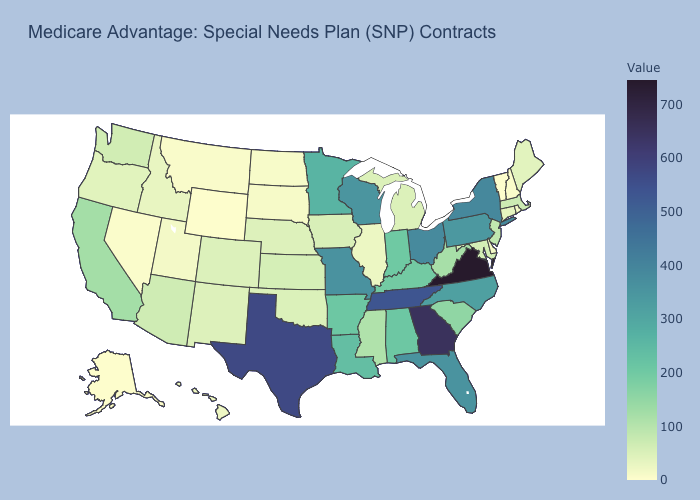Does Mississippi have a higher value than Arkansas?
Concise answer only. No. Is the legend a continuous bar?
Keep it brief. Yes. Does Florida have the lowest value in the USA?
Write a very short answer. No. Does Vermont have the lowest value in the USA?
Concise answer only. Yes. Does the map have missing data?
Concise answer only. No. Which states hav the highest value in the MidWest?
Give a very brief answer. Ohio. Is the legend a continuous bar?
Write a very short answer. Yes. Which states have the lowest value in the West?
Answer briefly. Alaska, Wyoming. Does New Mexico have the lowest value in the USA?
Concise answer only. No. 